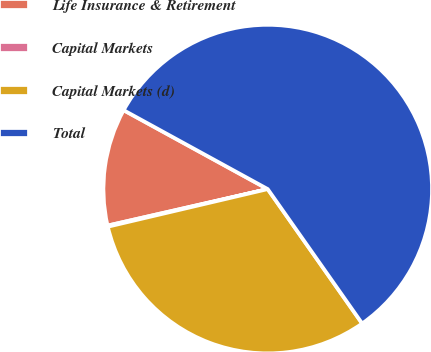<chart> <loc_0><loc_0><loc_500><loc_500><pie_chart><fcel>Life Insurance & Retirement<fcel>Capital Markets<fcel>Capital Markets (d)<fcel>Total<nl><fcel>11.54%<fcel>0.11%<fcel>31.07%<fcel>57.28%<nl></chart> 